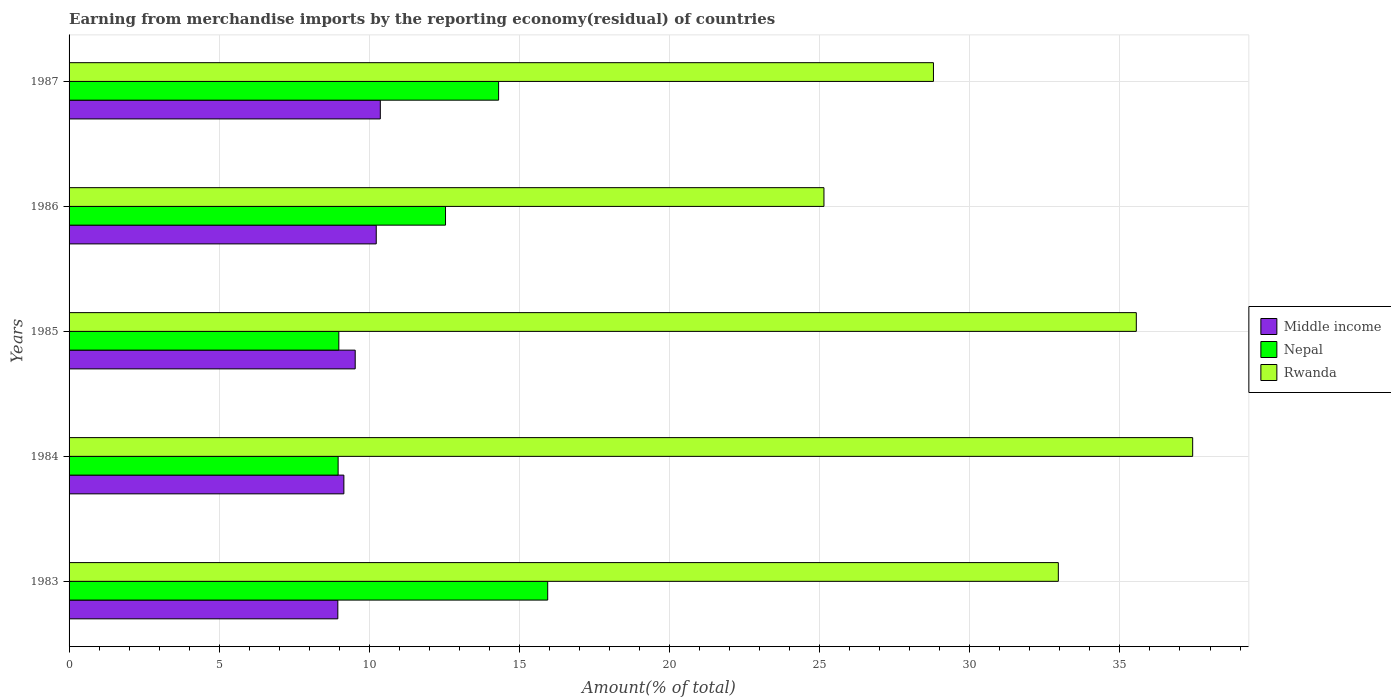How many groups of bars are there?
Make the answer very short. 5. Are the number of bars on each tick of the Y-axis equal?
Keep it short and to the point. Yes. How many bars are there on the 4th tick from the bottom?
Your answer should be very brief. 3. In how many cases, is the number of bars for a given year not equal to the number of legend labels?
Provide a succinct answer. 0. What is the percentage of amount earned from merchandise imports in Rwanda in 1987?
Provide a succinct answer. 28.79. Across all years, what is the maximum percentage of amount earned from merchandise imports in Middle income?
Offer a terse response. 10.37. Across all years, what is the minimum percentage of amount earned from merchandise imports in Rwanda?
Provide a succinct answer. 25.14. In which year was the percentage of amount earned from merchandise imports in Middle income minimum?
Your answer should be very brief. 1983. What is the total percentage of amount earned from merchandise imports in Rwanda in the graph?
Your response must be concise. 159.85. What is the difference between the percentage of amount earned from merchandise imports in Nepal in 1983 and that in 1987?
Offer a terse response. 1.63. What is the difference between the percentage of amount earned from merchandise imports in Nepal in 1987 and the percentage of amount earned from merchandise imports in Middle income in 1986?
Offer a terse response. 4.08. What is the average percentage of amount earned from merchandise imports in Middle income per year?
Your answer should be very brief. 9.65. In the year 1984, what is the difference between the percentage of amount earned from merchandise imports in Nepal and percentage of amount earned from merchandise imports in Middle income?
Ensure brevity in your answer.  -0.19. In how many years, is the percentage of amount earned from merchandise imports in Rwanda greater than 38 %?
Ensure brevity in your answer.  0. What is the ratio of the percentage of amount earned from merchandise imports in Middle income in 1983 to that in 1984?
Ensure brevity in your answer.  0.98. Is the percentage of amount earned from merchandise imports in Nepal in 1983 less than that in 1987?
Your answer should be compact. No. What is the difference between the highest and the second highest percentage of amount earned from merchandise imports in Nepal?
Offer a terse response. 1.63. What is the difference between the highest and the lowest percentage of amount earned from merchandise imports in Rwanda?
Give a very brief answer. 12.28. Is the sum of the percentage of amount earned from merchandise imports in Rwanda in 1983 and 1986 greater than the maximum percentage of amount earned from merchandise imports in Middle income across all years?
Make the answer very short. Yes. What does the 2nd bar from the top in 1983 represents?
Your answer should be very brief. Nepal. What does the 3rd bar from the bottom in 1985 represents?
Your response must be concise. Rwanda. How many years are there in the graph?
Give a very brief answer. 5. What is the difference between two consecutive major ticks on the X-axis?
Provide a succinct answer. 5. Are the values on the major ticks of X-axis written in scientific E-notation?
Provide a short and direct response. No. Does the graph contain any zero values?
Offer a terse response. No. Does the graph contain grids?
Make the answer very short. Yes. How are the legend labels stacked?
Provide a short and direct response. Vertical. What is the title of the graph?
Keep it short and to the point. Earning from merchandise imports by the reporting economy(residual) of countries. What is the label or title of the X-axis?
Offer a terse response. Amount(% of total). What is the label or title of the Y-axis?
Offer a very short reply. Years. What is the Amount(% of total) in Middle income in 1983?
Provide a succinct answer. 8.95. What is the Amount(% of total) of Nepal in 1983?
Make the answer very short. 15.94. What is the Amount(% of total) in Rwanda in 1983?
Your response must be concise. 32.95. What is the Amount(% of total) of Middle income in 1984?
Offer a terse response. 9.15. What is the Amount(% of total) of Nepal in 1984?
Keep it short and to the point. 8.96. What is the Amount(% of total) in Rwanda in 1984?
Make the answer very short. 37.42. What is the Amount(% of total) in Middle income in 1985?
Keep it short and to the point. 9.53. What is the Amount(% of total) in Nepal in 1985?
Ensure brevity in your answer.  8.98. What is the Amount(% of total) in Rwanda in 1985?
Offer a terse response. 35.55. What is the Amount(% of total) of Middle income in 1986?
Offer a terse response. 10.23. What is the Amount(% of total) in Nepal in 1986?
Ensure brevity in your answer.  12.54. What is the Amount(% of total) in Rwanda in 1986?
Your answer should be very brief. 25.14. What is the Amount(% of total) of Middle income in 1987?
Provide a short and direct response. 10.37. What is the Amount(% of total) in Nepal in 1987?
Keep it short and to the point. 14.31. What is the Amount(% of total) of Rwanda in 1987?
Provide a succinct answer. 28.79. Across all years, what is the maximum Amount(% of total) in Middle income?
Your answer should be compact. 10.37. Across all years, what is the maximum Amount(% of total) of Nepal?
Your answer should be compact. 15.94. Across all years, what is the maximum Amount(% of total) of Rwanda?
Your answer should be compact. 37.42. Across all years, what is the minimum Amount(% of total) of Middle income?
Provide a succinct answer. 8.95. Across all years, what is the minimum Amount(% of total) in Nepal?
Ensure brevity in your answer.  8.96. Across all years, what is the minimum Amount(% of total) of Rwanda?
Make the answer very short. 25.14. What is the total Amount(% of total) in Middle income in the graph?
Your answer should be compact. 48.23. What is the total Amount(% of total) in Nepal in the graph?
Your response must be concise. 60.73. What is the total Amount(% of total) of Rwanda in the graph?
Provide a short and direct response. 159.85. What is the difference between the Amount(% of total) in Middle income in 1983 and that in 1984?
Keep it short and to the point. -0.2. What is the difference between the Amount(% of total) of Nepal in 1983 and that in 1984?
Make the answer very short. 6.98. What is the difference between the Amount(% of total) in Rwanda in 1983 and that in 1984?
Make the answer very short. -4.47. What is the difference between the Amount(% of total) of Middle income in 1983 and that in 1985?
Offer a terse response. -0.58. What is the difference between the Amount(% of total) in Nepal in 1983 and that in 1985?
Provide a succinct answer. 6.96. What is the difference between the Amount(% of total) of Rwanda in 1983 and that in 1985?
Your answer should be compact. -2.6. What is the difference between the Amount(% of total) in Middle income in 1983 and that in 1986?
Your answer should be compact. -1.28. What is the difference between the Amount(% of total) of Nepal in 1983 and that in 1986?
Make the answer very short. 3.4. What is the difference between the Amount(% of total) of Rwanda in 1983 and that in 1986?
Your answer should be compact. 7.81. What is the difference between the Amount(% of total) in Middle income in 1983 and that in 1987?
Give a very brief answer. -1.41. What is the difference between the Amount(% of total) of Nepal in 1983 and that in 1987?
Provide a succinct answer. 1.63. What is the difference between the Amount(% of total) of Rwanda in 1983 and that in 1987?
Your response must be concise. 4.16. What is the difference between the Amount(% of total) of Middle income in 1984 and that in 1985?
Ensure brevity in your answer.  -0.38. What is the difference between the Amount(% of total) of Nepal in 1984 and that in 1985?
Provide a short and direct response. -0.02. What is the difference between the Amount(% of total) of Rwanda in 1984 and that in 1985?
Ensure brevity in your answer.  1.88. What is the difference between the Amount(% of total) in Middle income in 1984 and that in 1986?
Provide a succinct answer. -1.08. What is the difference between the Amount(% of total) of Nepal in 1984 and that in 1986?
Offer a terse response. -3.58. What is the difference between the Amount(% of total) of Rwanda in 1984 and that in 1986?
Provide a short and direct response. 12.28. What is the difference between the Amount(% of total) of Middle income in 1984 and that in 1987?
Your answer should be very brief. -1.21. What is the difference between the Amount(% of total) of Nepal in 1984 and that in 1987?
Provide a succinct answer. -5.35. What is the difference between the Amount(% of total) of Rwanda in 1984 and that in 1987?
Make the answer very short. 8.63. What is the difference between the Amount(% of total) in Middle income in 1985 and that in 1986?
Offer a terse response. -0.7. What is the difference between the Amount(% of total) in Nepal in 1985 and that in 1986?
Offer a terse response. -3.55. What is the difference between the Amount(% of total) in Rwanda in 1985 and that in 1986?
Give a very brief answer. 10.4. What is the difference between the Amount(% of total) in Middle income in 1985 and that in 1987?
Give a very brief answer. -0.84. What is the difference between the Amount(% of total) in Nepal in 1985 and that in 1987?
Give a very brief answer. -5.32. What is the difference between the Amount(% of total) in Rwanda in 1985 and that in 1987?
Offer a terse response. 6.76. What is the difference between the Amount(% of total) of Middle income in 1986 and that in 1987?
Offer a terse response. -0.14. What is the difference between the Amount(% of total) of Nepal in 1986 and that in 1987?
Your answer should be compact. -1.77. What is the difference between the Amount(% of total) of Rwanda in 1986 and that in 1987?
Keep it short and to the point. -3.65. What is the difference between the Amount(% of total) in Middle income in 1983 and the Amount(% of total) in Nepal in 1984?
Offer a very short reply. -0.01. What is the difference between the Amount(% of total) in Middle income in 1983 and the Amount(% of total) in Rwanda in 1984?
Make the answer very short. -28.47. What is the difference between the Amount(% of total) of Nepal in 1983 and the Amount(% of total) of Rwanda in 1984?
Offer a very short reply. -21.48. What is the difference between the Amount(% of total) of Middle income in 1983 and the Amount(% of total) of Nepal in 1985?
Your response must be concise. -0.03. What is the difference between the Amount(% of total) of Middle income in 1983 and the Amount(% of total) of Rwanda in 1985?
Offer a very short reply. -26.59. What is the difference between the Amount(% of total) in Nepal in 1983 and the Amount(% of total) in Rwanda in 1985?
Your answer should be compact. -19.6. What is the difference between the Amount(% of total) of Middle income in 1983 and the Amount(% of total) of Nepal in 1986?
Offer a terse response. -3.59. What is the difference between the Amount(% of total) of Middle income in 1983 and the Amount(% of total) of Rwanda in 1986?
Your answer should be very brief. -16.19. What is the difference between the Amount(% of total) in Nepal in 1983 and the Amount(% of total) in Rwanda in 1986?
Your answer should be very brief. -9.2. What is the difference between the Amount(% of total) of Middle income in 1983 and the Amount(% of total) of Nepal in 1987?
Keep it short and to the point. -5.36. What is the difference between the Amount(% of total) in Middle income in 1983 and the Amount(% of total) in Rwanda in 1987?
Keep it short and to the point. -19.84. What is the difference between the Amount(% of total) in Nepal in 1983 and the Amount(% of total) in Rwanda in 1987?
Keep it short and to the point. -12.85. What is the difference between the Amount(% of total) of Middle income in 1984 and the Amount(% of total) of Nepal in 1985?
Your response must be concise. 0.17. What is the difference between the Amount(% of total) in Middle income in 1984 and the Amount(% of total) in Rwanda in 1985?
Provide a short and direct response. -26.39. What is the difference between the Amount(% of total) of Nepal in 1984 and the Amount(% of total) of Rwanda in 1985?
Give a very brief answer. -26.58. What is the difference between the Amount(% of total) of Middle income in 1984 and the Amount(% of total) of Nepal in 1986?
Keep it short and to the point. -3.39. What is the difference between the Amount(% of total) of Middle income in 1984 and the Amount(% of total) of Rwanda in 1986?
Make the answer very short. -15.99. What is the difference between the Amount(% of total) in Nepal in 1984 and the Amount(% of total) in Rwanda in 1986?
Give a very brief answer. -16.18. What is the difference between the Amount(% of total) in Middle income in 1984 and the Amount(% of total) in Nepal in 1987?
Make the answer very short. -5.15. What is the difference between the Amount(% of total) in Middle income in 1984 and the Amount(% of total) in Rwanda in 1987?
Your response must be concise. -19.64. What is the difference between the Amount(% of total) of Nepal in 1984 and the Amount(% of total) of Rwanda in 1987?
Your answer should be very brief. -19.83. What is the difference between the Amount(% of total) of Middle income in 1985 and the Amount(% of total) of Nepal in 1986?
Make the answer very short. -3.01. What is the difference between the Amount(% of total) of Middle income in 1985 and the Amount(% of total) of Rwanda in 1986?
Make the answer very short. -15.61. What is the difference between the Amount(% of total) of Nepal in 1985 and the Amount(% of total) of Rwanda in 1986?
Offer a terse response. -16.16. What is the difference between the Amount(% of total) of Middle income in 1985 and the Amount(% of total) of Nepal in 1987?
Your answer should be compact. -4.78. What is the difference between the Amount(% of total) of Middle income in 1985 and the Amount(% of total) of Rwanda in 1987?
Provide a succinct answer. -19.26. What is the difference between the Amount(% of total) of Nepal in 1985 and the Amount(% of total) of Rwanda in 1987?
Make the answer very short. -19.8. What is the difference between the Amount(% of total) in Middle income in 1986 and the Amount(% of total) in Nepal in 1987?
Your response must be concise. -4.08. What is the difference between the Amount(% of total) in Middle income in 1986 and the Amount(% of total) in Rwanda in 1987?
Offer a very short reply. -18.56. What is the difference between the Amount(% of total) of Nepal in 1986 and the Amount(% of total) of Rwanda in 1987?
Make the answer very short. -16.25. What is the average Amount(% of total) of Middle income per year?
Give a very brief answer. 9.65. What is the average Amount(% of total) of Nepal per year?
Provide a succinct answer. 12.15. What is the average Amount(% of total) in Rwanda per year?
Ensure brevity in your answer.  31.97. In the year 1983, what is the difference between the Amount(% of total) in Middle income and Amount(% of total) in Nepal?
Offer a terse response. -6.99. In the year 1983, what is the difference between the Amount(% of total) in Middle income and Amount(% of total) in Rwanda?
Your response must be concise. -24. In the year 1983, what is the difference between the Amount(% of total) of Nepal and Amount(% of total) of Rwanda?
Offer a terse response. -17.01. In the year 1984, what is the difference between the Amount(% of total) of Middle income and Amount(% of total) of Nepal?
Your answer should be compact. 0.19. In the year 1984, what is the difference between the Amount(% of total) in Middle income and Amount(% of total) in Rwanda?
Keep it short and to the point. -28.27. In the year 1984, what is the difference between the Amount(% of total) in Nepal and Amount(% of total) in Rwanda?
Keep it short and to the point. -28.46. In the year 1985, what is the difference between the Amount(% of total) in Middle income and Amount(% of total) in Nepal?
Offer a very short reply. 0.55. In the year 1985, what is the difference between the Amount(% of total) of Middle income and Amount(% of total) of Rwanda?
Make the answer very short. -26.02. In the year 1985, what is the difference between the Amount(% of total) of Nepal and Amount(% of total) of Rwanda?
Provide a succinct answer. -26.56. In the year 1986, what is the difference between the Amount(% of total) of Middle income and Amount(% of total) of Nepal?
Your answer should be very brief. -2.31. In the year 1986, what is the difference between the Amount(% of total) of Middle income and Amount(% of total) of Rwanda?
Offer a terse response. -14.91. In the year 1986, what is the difference between the Amount(% of total) of Nepal and Amount(% of total) of Rwanda?
Ensure brevity in your answer.  -12.6. In the year 1987, what is the difference between the Amount(% of total) in Middle income and Amount(% of total) in Nepal?
Offer a terse response. -3.94. In the year 1987, what is the difference between the Amount(% of total) of Middle income and Amount(% of total) of Rwanda?
Provide a succinct answer. -18.42. In the year 1987, what is the difference between the Amount(% of total) of Nepal and Amount(% of total) of Rwanda?
Give a very brief answer. -14.48. What is the ratio of the Amount(% of total) of Nepal in 1983 to that in 1984?
Offer a very short reply. 1.78. What is the ratio of the Amount(% of total) of Rwanda in 1983 to that in 1984?
Your answer should be compact. 0.88. What is the ratio of the Amount(% of total) in Middle income in 1983 to that in 1985?
Ensure brevity in your answer.  0.94. What is the ratio of the Amount(% of total) of Nepal in 1983 to that in 1985?
Give a very brief answer. 1.77. What is the ratio of the Amount(% of total) in Rwanda in 1983 to that in 1985?
Your response must be concise. 0.93. What is the ratio of the Amount(% of total) in Middle income in 1983 to that in 1986?
Ensure brevity in your answer.  0.87. What is the ratio of the Amount(% of total) of Nepal in 1983 to that in 1986?
Offer a very short reply. 1.27. What is the ratio of the Amount(% of total) in Rwanda in 1983 to that in 1986?
Give a very brief answer. 1.31. What is the ratio of the Amount(% of total) of Middle income in 1983 to that in 1987?
Your answer should be compact. 0.86. What is the ratio of the Amount(% of total) in Nepal in 1983 to that in 1987?
Offer a very short reply. 1.11. What is the ratio of the Amount(% of total) of Rwanda in 1983 to that in 1987?
Your response must be concise. 1.14. What is the ratio of the Amount(% of total) in Middle income in 1984 to that in 1985?
Your answer should be compact. 0.96. What is the ratio of the Amount(% of total) of Rwanda in 1984 to that in 1985?
Your answer should be compact. 1.05. What is the ratio of the Amount(% of total) in Middle income in 1984 to that in 1986?
Make the answer very short. 0.89. What is the ratio of the Amount(% of total) in Nepal in 1984 to that in 1986?
Offer a very short reply. 0.71. What is the ratio of the Amount(% of total) of Rwanda in 1984 to that in 1986?
Offer a terse response. 1.49. What is the ratio of the Amount(% of total) in Middle income in 1984 to that in 1987?
Your response must be concise. 0.88. What is the ratio of the Amount(% of total) in Nepal in 1984 to that in 1987?
Give a very brief answer. 0.63. What is the ratio of the Amount(% of total) in Rwanda in 1984 to that in 1987?
Your answer should be compact. 1.3. What is the ratio of the Amount(% of total) in Middle income in 1985 to that in 1986?
Keep it short and to the point. 0.93. What is the ratio of the Amount(% of total) in Nepal in 1985 to that in 1986?
Keep it short and to the point. 0.72. What is the ratio of the Amount(% of total) of Rwanda in 1985 to that in 1986?
Offer a terse response. 1.41. What is the ratio of the Amount(% of total) in Middle income in 1985 to that in 1987?
Offer a very short reply. 0.92. What is the ratio of the Amount(% of total) in Nepal in 1985 to that in 1987?
Your answer should be very brief. 0.63. What is the ratio of the Amount(% of total) in Rwanda in 1985 to that in 1987?
Offer a very short reply. 1.23. What is the ratio of the Amount(% of total) of Nepal in 1986 to that in 1987?
Ensure brevity in your answer.  0.88. What is the ratio of the Amount(% of total) of Rwanda in 1986 to that in 1987?
Provide a succinct answer. 0.87. What is the difference between the highest and the second highest Amount(% of total) of Middle income?
Your response must be concise. 0.14. What is the difference between the highest and the second highest Amount(% of total) of Nepal?
Your answer should be very brief. 1.63. What is the difference between the highest and the second highest Amount(% of total) of Rwanda?
Your answer should be very brief. 1.88. What is the difference between the highest and the lowest Amount(% of total) in Middle income?
Offer a very short reply. 1.41. What is the difference between the highest and the lowest Amount(% of total) in Nepal?
Your answer should be very brief. 6.98. What is the difference between the highest and the lowest Amount(% of total) of Rwanda?
Offer a terse response. 12.28. 